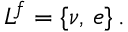Convert formula to latex. <formula><loc_0><loc_0><loc_500><loc_500>L ^ { f } = \{ \nu , \, e \} \, .</formula> 